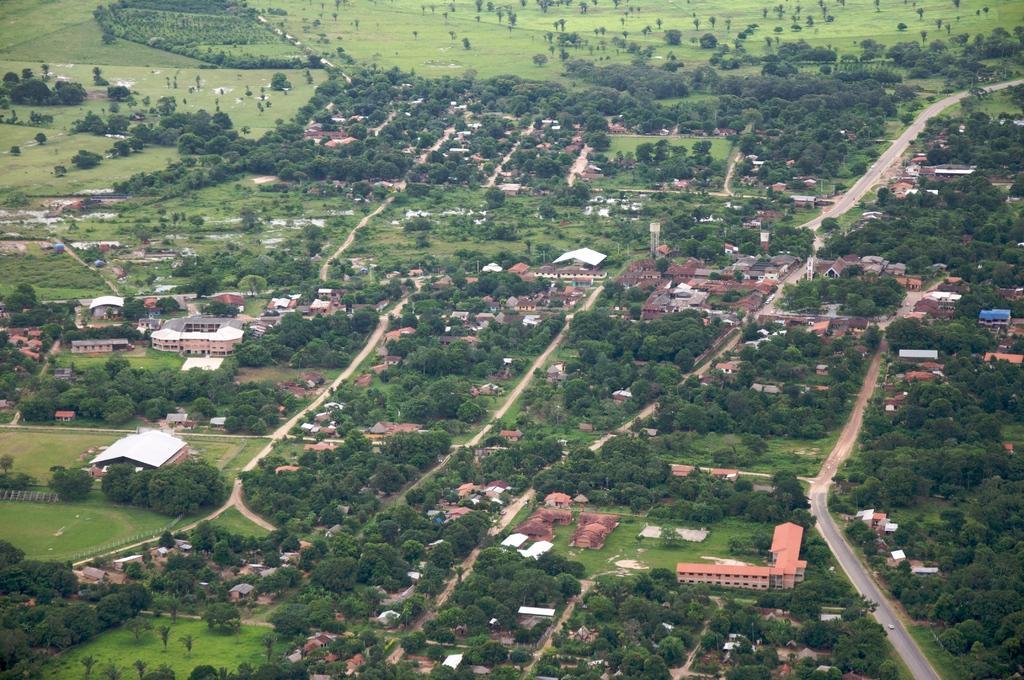How would you summarize this image in a sentence or two? This is an aerial view of an image where we can see the roads, buildings, trees and the grasslands. 